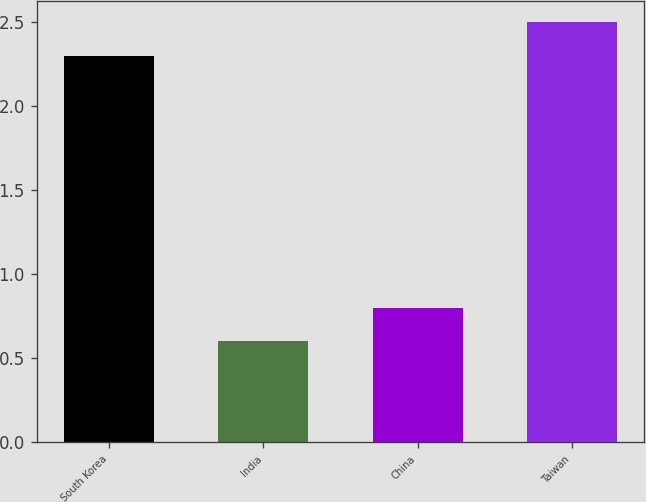<chart> <loc_0><loc_0><loc_500><loc_500><bar_chart><fcel>South Korea<fcel>India<fcel>China<fcel>Taiwan<nl><fcel>2.3<fcel>0.6<fcel>0.8<fcel>2.5<nl></chart> 